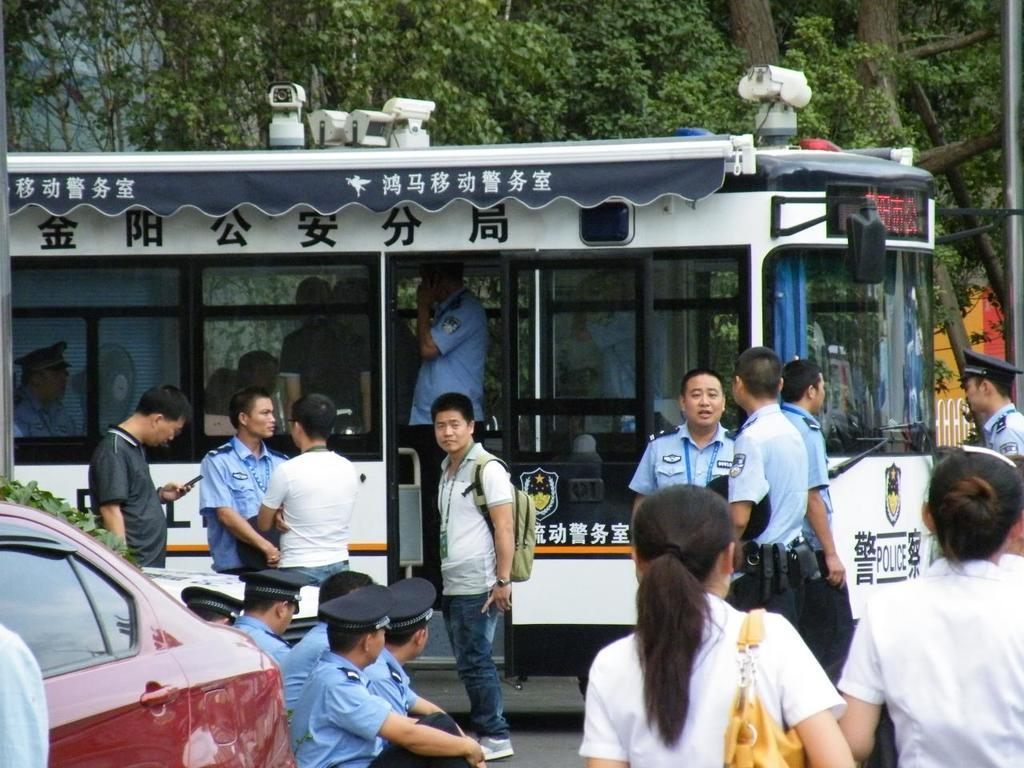<image>
Share a concise interpretation of the image provided. A trolley type of vehicle is owned by the Police department. 